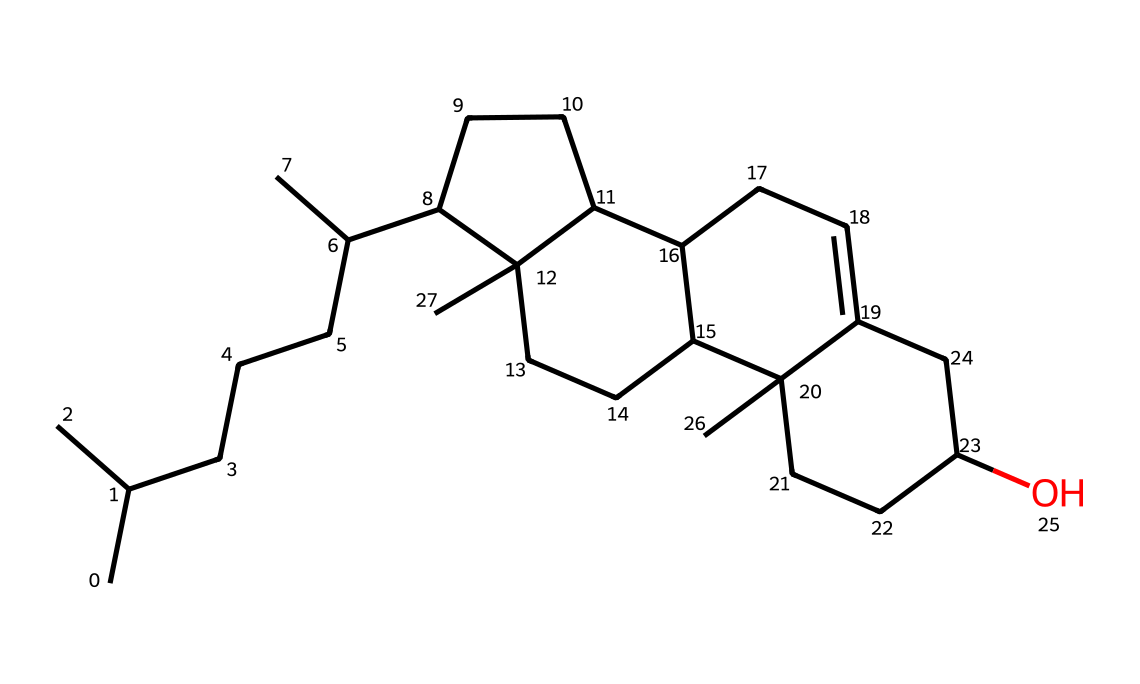What is the main functional group present in cholesterol? The molecule contains a hydroxyl group (–OH), which characterizes it as a sterol. This group can be identified in the structure where there is an alcohol functional group.
Answer: hydroxyl How many carbon atoms are in the cholesterol structure? By analyzing the SMILES representation, we can count the number of carbon atoms represented. There are 27 carbon atoms in total, indicated by the 'C' symbols in the structure.
Answer: 27 Does cholesterol contain any double bonds in its structure? By examining the SMILES string for any '=' signs that indicate double bonds, we find that there is one double bond present in the structure, specifically within the cycloalkene ring.
Answer: yes What type of lipid is cholesterol classified as? Cholesterol is classified as a sterol due to its multi-ring structure and presence of hydroxyl group, which are characteristic features of this lipid subclass.
Answer: sterol What is the molecular formula for cholesterol? The molecular formula can be derived from the SMILES by counting the respective atoms: C: 27, H: 46, O: 1. Putting this together gives us C27H46O.
Answer: C27H46O How many rings are present in the cholesterol structure? There are four interconnected hydrocarbon rings in the structure of cholesterol, which is typical for sterols. This can be observed in the cyclical arrangement of carbon atoms in the SMILES.
Answer: four 